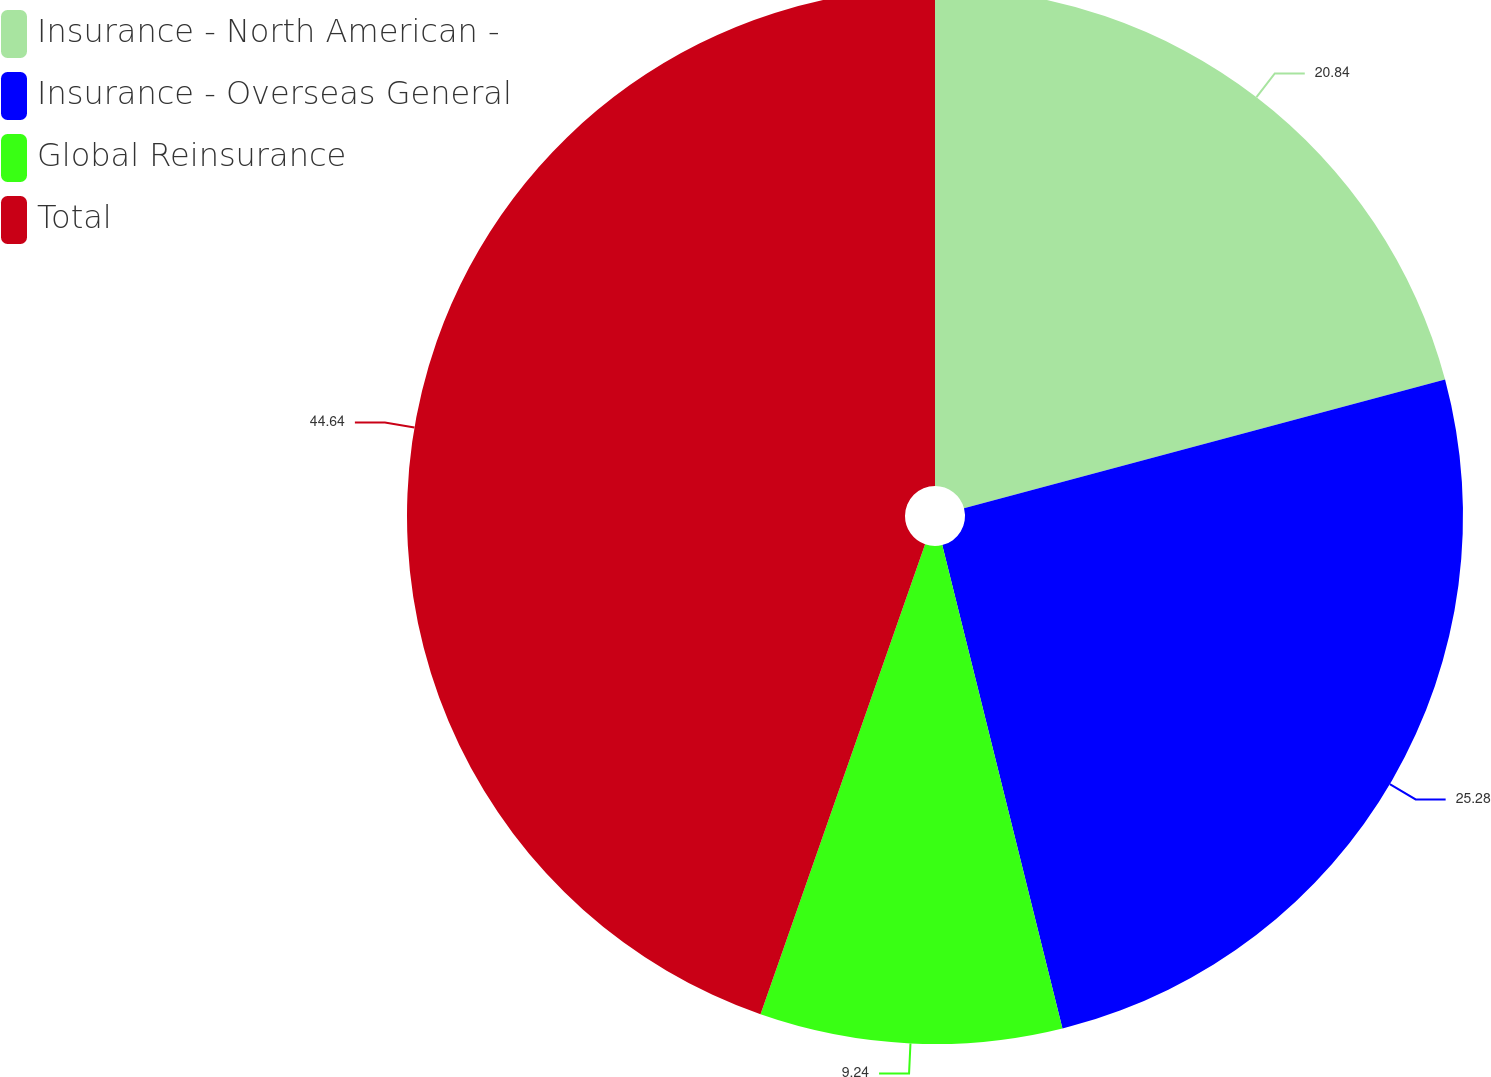<chart> <loc_0><loc_0><loc_500><loc_500><pie_chart><fcel>Insurance - North American -<fcel>Insurance - Overseas General<fcel>Global Reinsurance<fcel>Total<nl><fcel>20.84%<fcel>25.28%<fcel>9.24%<fcel>44.64%<nl></chart> 